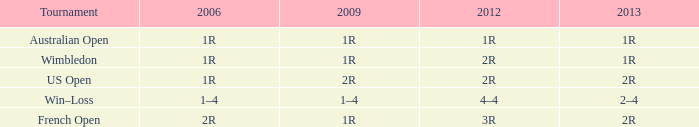What is the Tournament when the 2013 is 2r, and a 2006 is 1r? US Open. 